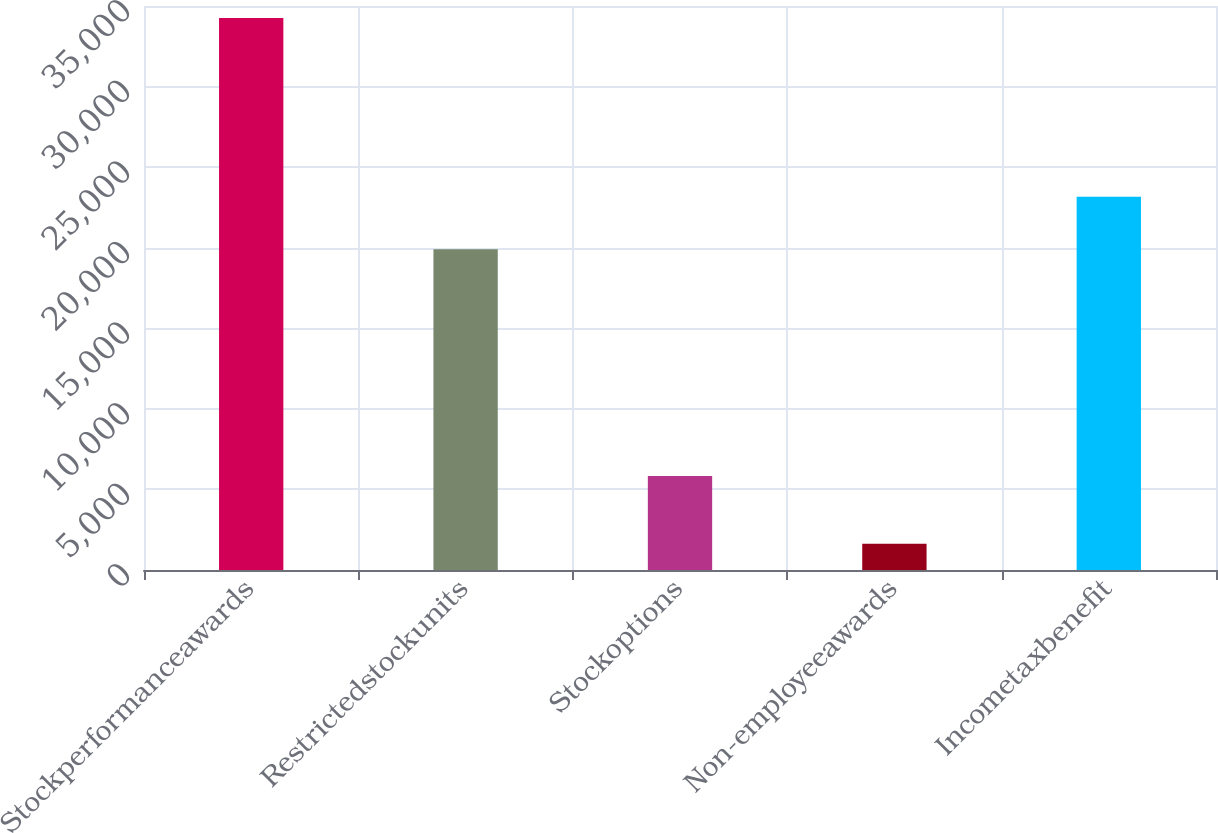<chart> <loc_0><loc_0><loc_500><loc_500><bar_chart><fcel>Stockperformanceawards<fcel>Restrictedstockunits<fcel>Stockoptions<fcel>Non-employeeawards<fcel>Incometaxbenefit<nl><fcel>34248<fcel>19908<fcel>5838<fcel>1630<fcel>23169.8<nl></chart> 